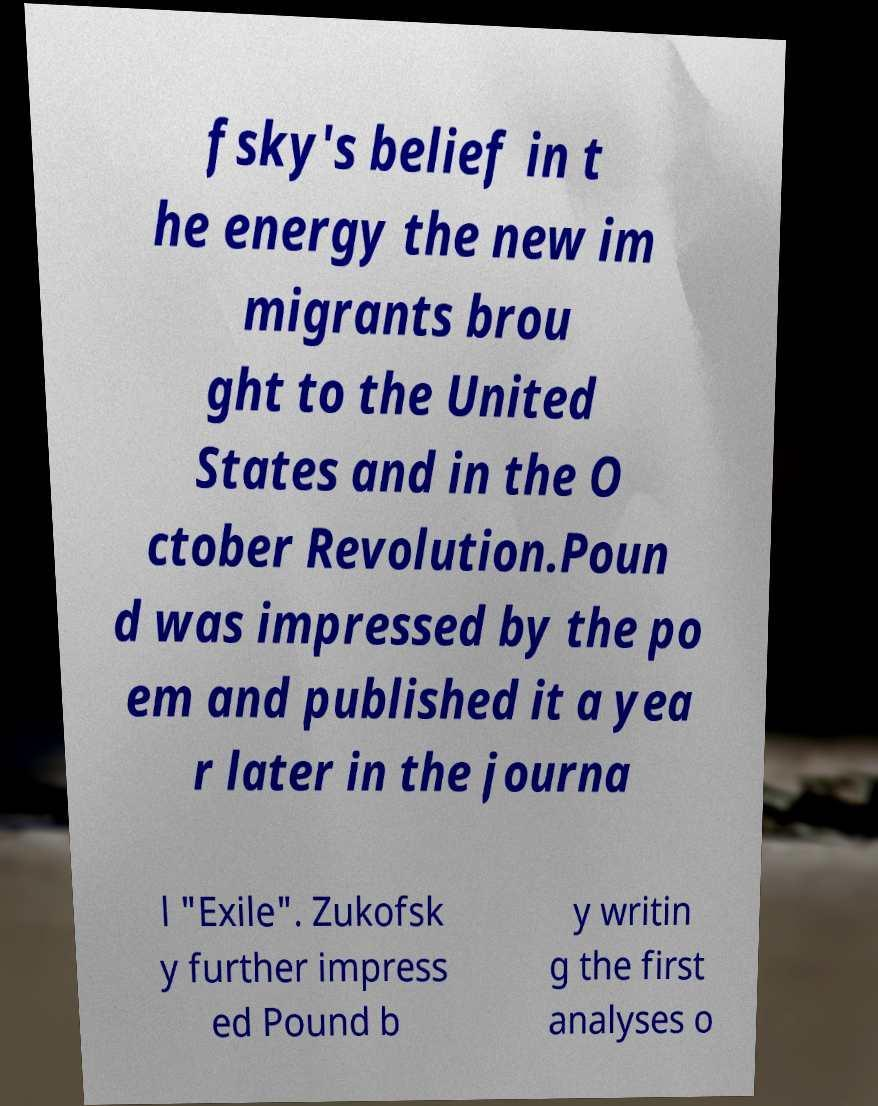For documentation purposes, I need the text within this image transcribed. Could you provide that? fsky's belief in t he energy the new im migrants brou ght to the United States and in the O ctober Revolution.Poun d was impressed by the po em and published it a yea r later in the journa l "Exile". Zukofsk y further impress ed Pound b y writin g the first analyses o 